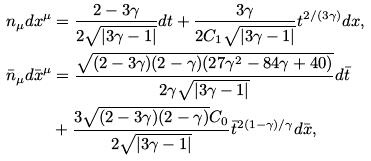<formula> <loc_0><loc_0><loc_500><loc_500>n _ { \mu } d x ^ { \mu } & = \frac { 2 - 3 \gamma } { 2 \sqrt { | 3 \gamma - 1 | } } d t + \frac { 3 \gamma } { 2 C _ { 1 } \sqrt { | 3 \gamma - 1 | } } t ^ { 2 / ( 3 \gamma ) } d x , \\ { \bar { n } } _ { \mu } d { \bar { x } } ^ { \mu } & = \frac { \sqrt { ( 2 - 3 \gamma ) ( 2 - \gamma ) ( 2 7 \gamma ^ { 2 } - 8 4 \gamma + 4 0 ) } } { 2 \gamma \sqrt { | 3 \gamma - 1 | } } d { \bar { t } } \\ & + \frac { 3 \sqrt { ( 2 - 3 \gamma ) ( 2 - \gamma ) } C _ { 0 } } { 2 \sqrt { | 3 \gamma - 1 | } } { \bar { t } } ^ { 2 ( 1 - \gamma ) / \gamma } d { \bar { x } } ,</formula> 